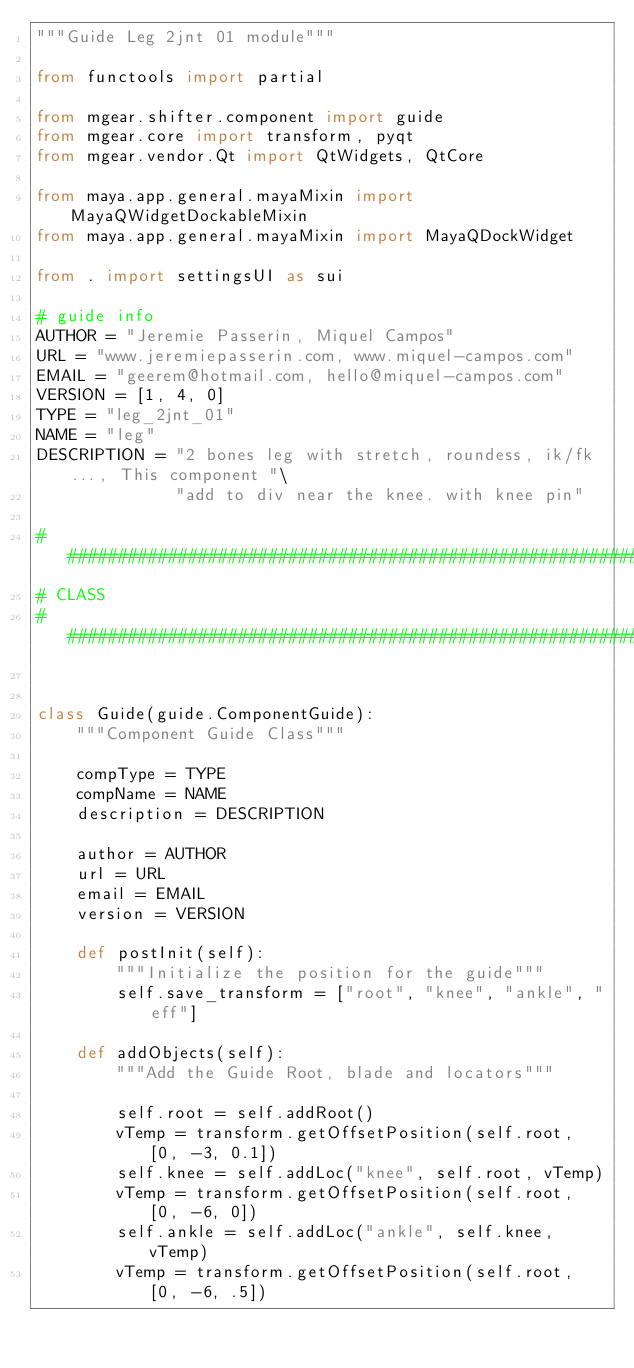Convert code to text. <code><loc_0><loc_0><loc_500><loc_500><_Python_>"""Guide Leg 2jnt 01 module"""

from functools import partial

from mgear.shifter.component import guide
from mgear.core import transform, pyqt
from mgear.vendor.Qt import QtWidgets, QtCore

from maya.app.general.mayaMixin import MayaQWidgetDockableMixin
from maya.app.general.mayaMixin import MayaQDockWidget

from . import settingsUI as sui

# guide info
AUTHOR = "Jeremie Passerin, Miquel Campos"
URL = "www.jeremiepasserin.com, www.miquel-campos.com"
EMAIL = "geerem@hotmail.com, hello@miquel-campos.com"
VERSION = [1, 4, 0]
TYPE = "leg_2jnt_01"
NAME = "leg"
DESCRIPTION = "2 bones leg with stretch, roundess, ik/fk..., This component "\
              "add to div near the knee. with knee pin"

##########################################################
# CLASS
##########################################################


class Guide(guide.ComponentGuide):
    """Component Guide Class"""

    compType = TYPE
    compName = NAME
    description = DESCRIPTION

    author = AUTHOR
    url = URL
    email = EMAIL
    version = VERSION

    def postInit(self):
        """Initialize the position for the guide"""
        self.save_transform = ["root", "knee", "ankle", "eff"]

    def addObjects(self):
        """Add the Guide Root, blade and locators"""

        self.root = self.addRoot()
        vTemp = transform.getOffsetPosition(self.root, [0, -3, 0.1])
        self.knee = self.addLoc("knee", self.root, vTemp)
        vTemp = transform.getOffsetPosition(self.root, [0, -6, 0])
        self.ankle = self.addLoc("ankle", self.knee, vTemp)
        vTemp = transform.getOffsetPosition(self.root, [0, -6, .5])</code> 